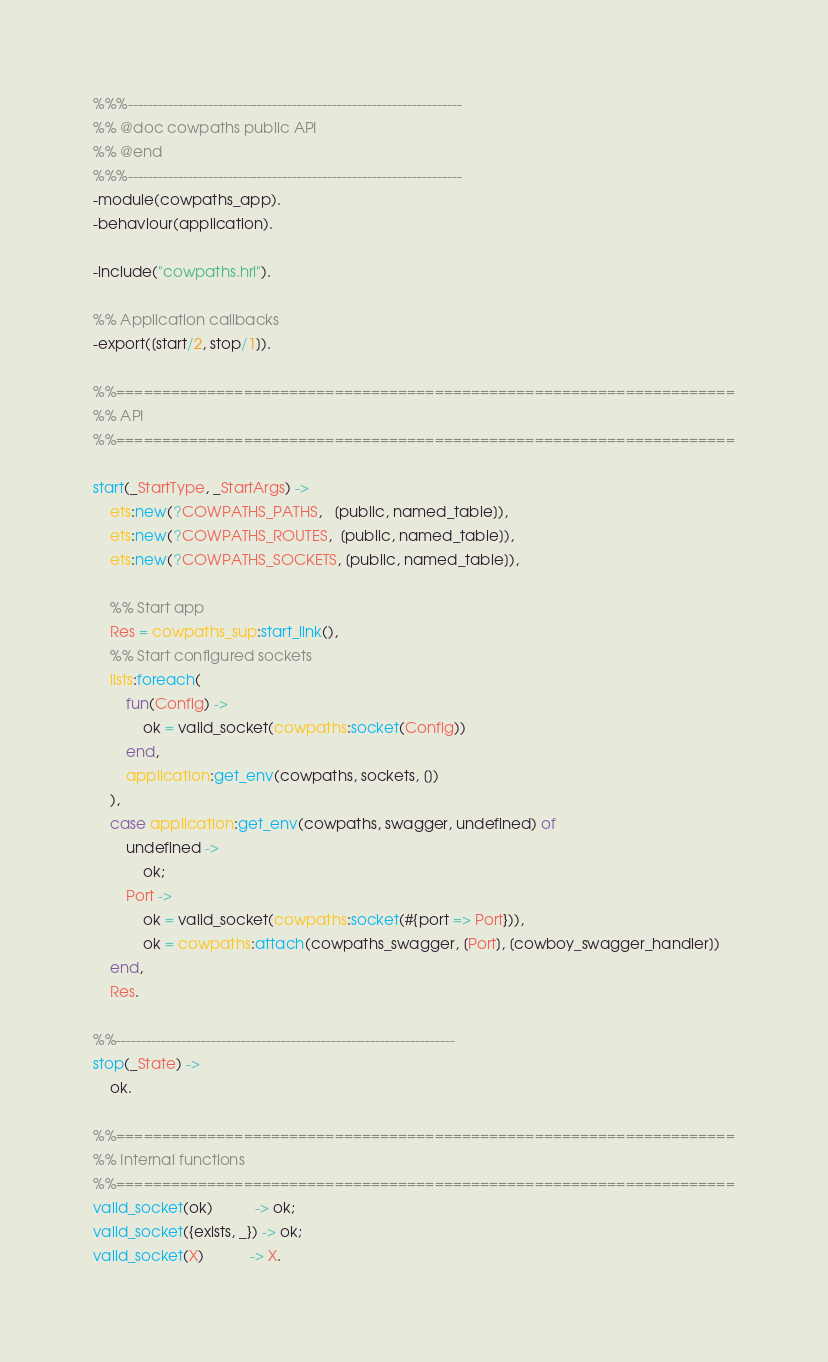<code> <loc_0><loc_0><loc_500><loc_500><_Erlang_>%%%-------------------------------------------------------------------
%% @doc cowpaths public API
%% @end
%%%-------------------------------------------------------------------
-module(cowpaths_app).
-behaviour(application).

-include("cowpaths.hrl").

%% Application callbacks
-export([start/2, stop/1]).

%%====================================================================
%% API
%%====================================================================

start(_StartType, _StartArgs) ->
	ets:new(?COWPATHS_PATHS,   [public, named_table]),
	ets:new(?COWPATHS_ROUTES,  [public, named_table]),
	ets:new(?COWPATHS_SOCKETS, [public, named_table]),

	%% Start app    
    Res = cowpaths_sup:start_link(),
    %% Start configured sockets
    lists:foreach(
		fun(Config) ->
			ok = valid_socket(cowpaths:socket(Config))
		end,
		application:get_env(cowpaths, sockets, [])
	),
    case application:get_env(cowpaths, swagger, undefined) of
    	undefined ->
    		ok;
    	Port ->
    		ok = valid_socket(cowpaths:socket(#{port => Port})),
    		ok = cowpaths:attach(cowpaths_swagger, [Port], [cowboy_swagger_handler])
    end,
    Res.

%%--------------------------------------------------------------------
stop(_State) ->
    ok.

%%====================================================================
%% Internal functions
%%====================================================================
valid_socket(ok)          -> ok;
valid_socket({exists, _}) -> ok;
valid_socket(X)           -> X.
</code> 